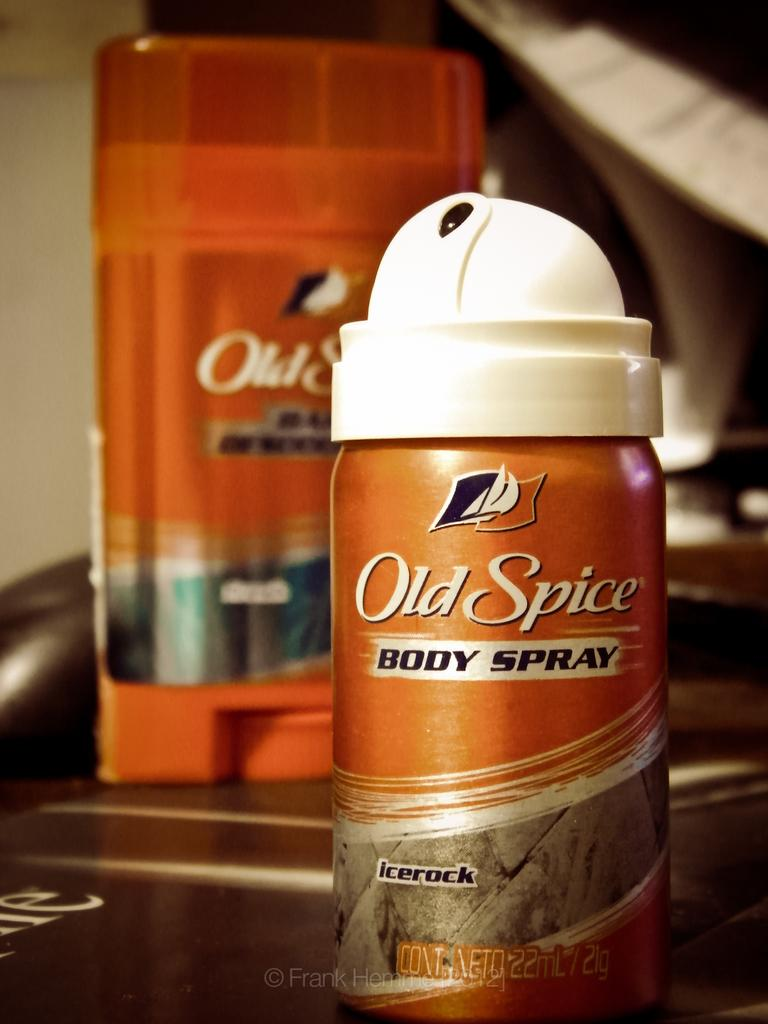<image>
Summarize the visual content of the image. A bottle of Old Spice Body Spray in an orange can. 